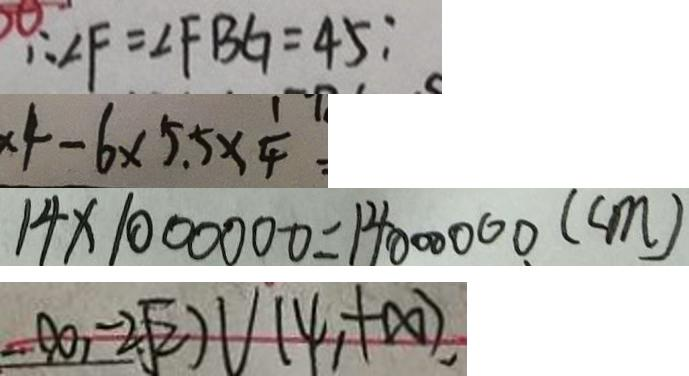<formula> <loc_0><loc_0><loc_500><loc_500>\therefore \angle F = \angle F B G = 4 5 : 
 \times 4 - 6 \times 5 . 5 \times \frac { 1 } { 4 } = 
 1 4 \times 1 0 0 0 0 0 0 = 1 4 0 0 0 0 0 0 ( c m ) 
 - \infty , - 2 \sqrt { 2 } ) \cup ( \varphi , + \infty , ) ,</formula> 